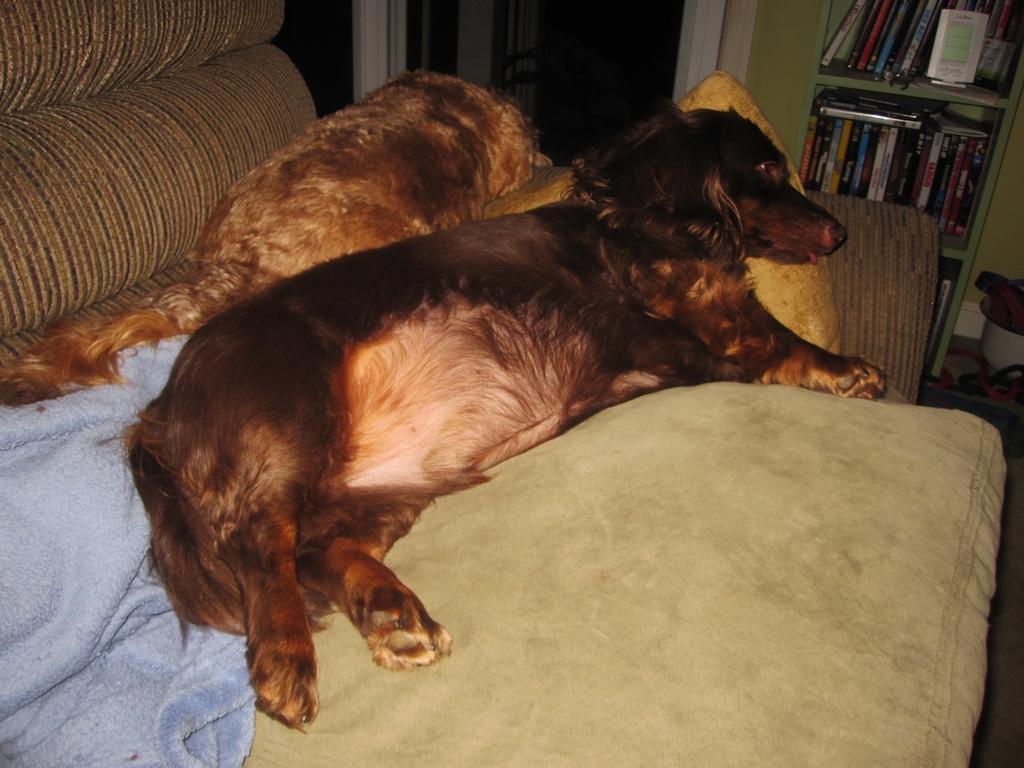Could you give a brief overview of what you see in this image? In this image i can see two animals on the sofa, towel on it, on the right there is a cupboard with books, near that i can see the door. 